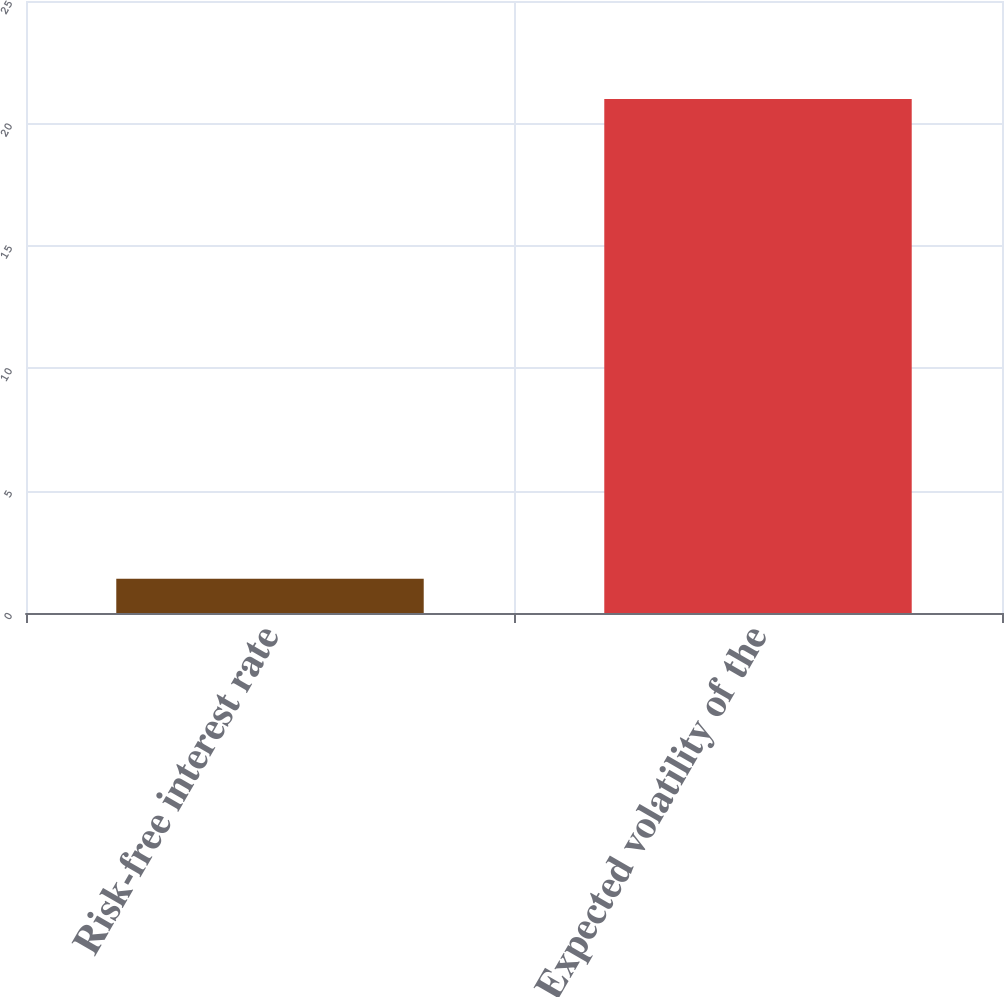<chart> <loc_0><loc_0><loc_500><loc_500><bar_chart><fcel>Risk-free interest rate<fcel>Expected volatility of the<nl><fcel>1.4<fcel>21<nl></chart> 